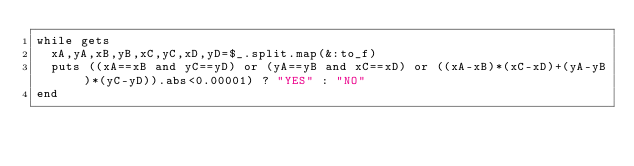<code> <loc_0><loc_0><loc_500><loc_500><_Ruby_>while gets
  xA,yA,xB,yB,xC,yC,xD,yD=$_.split.map(&:to_f)
  puts ((xA==xB and yC==yD) or (yA==yB and xC==xD) or ((xA-xB)*(xC-xD)+(yA-yB)*(yC-yD)).abs<0.00001) ? "YES" : "NO"
end</code> 